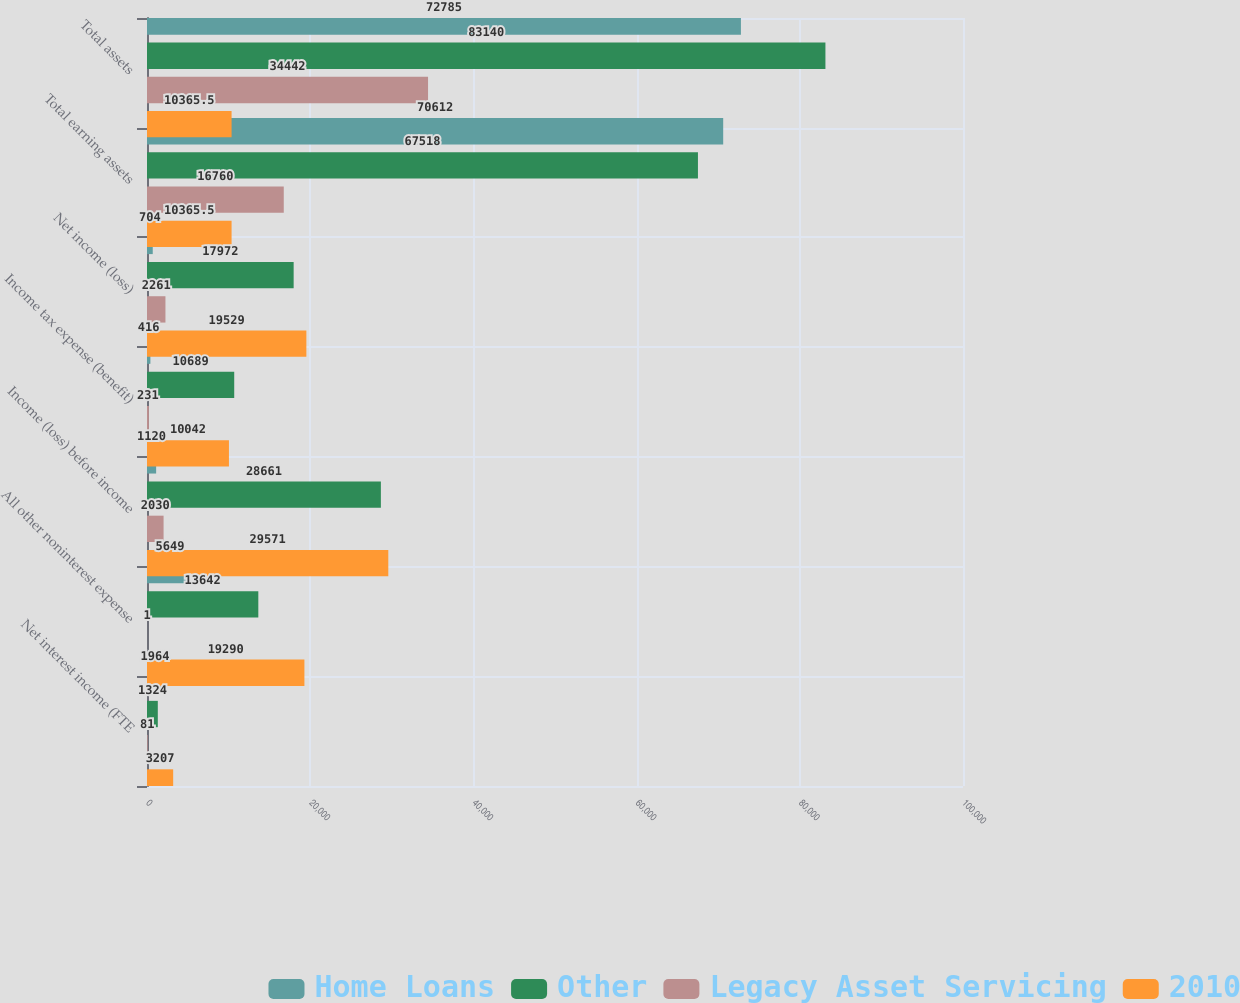<chart> <loc_0><loc_0><loc_500><loc_500><stacked_bar_chart><ecel><fcel>Net interest income (FTE<fcel>All other noninterest expense<fcel>Income (loss) before income<fcel>Income tax expense (benefit)<fcel>Net income (loss)<fcel>Total earning assets<fcel>Total assets<nl><fcel>Home Loans<fcel>1964<fcel>5649<fcel>1120<fcel>416<fcel>704<fcel>70612<fcel>72785<nl><fcel>Other<fcel>1324<fcel>13642<fcel>28661<fcel>10689<fcel>17972<fcel>67518<fcel>83140<nl><fcel>Legacy Asset Servicing<fcel>81<fcel>1<fcel>2030<fcel>231<fcel>2261<fcel>16760<fcel>34442<nl><fcel>2010<fcel>3207<fcel>19290<fcel>29571<fcel>10042<fcel>19529<fcel>10365.5<fcel>10365.5<nl></chart> 